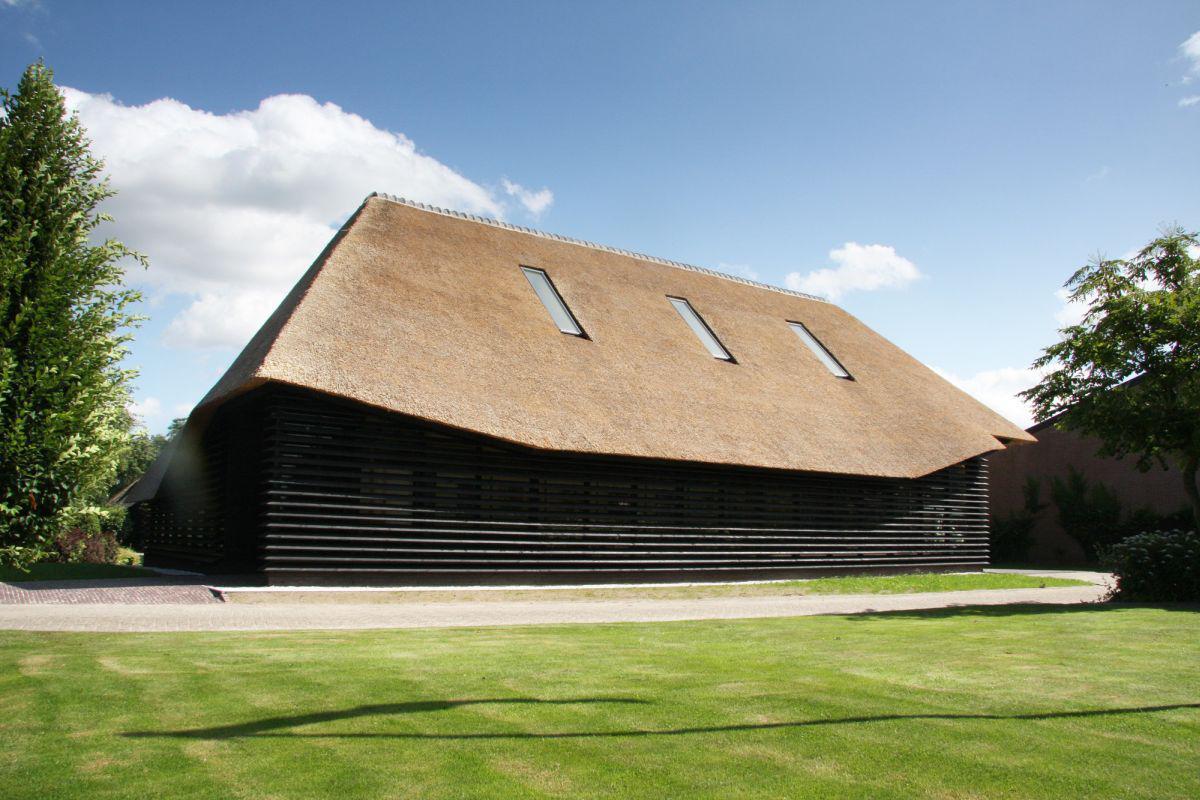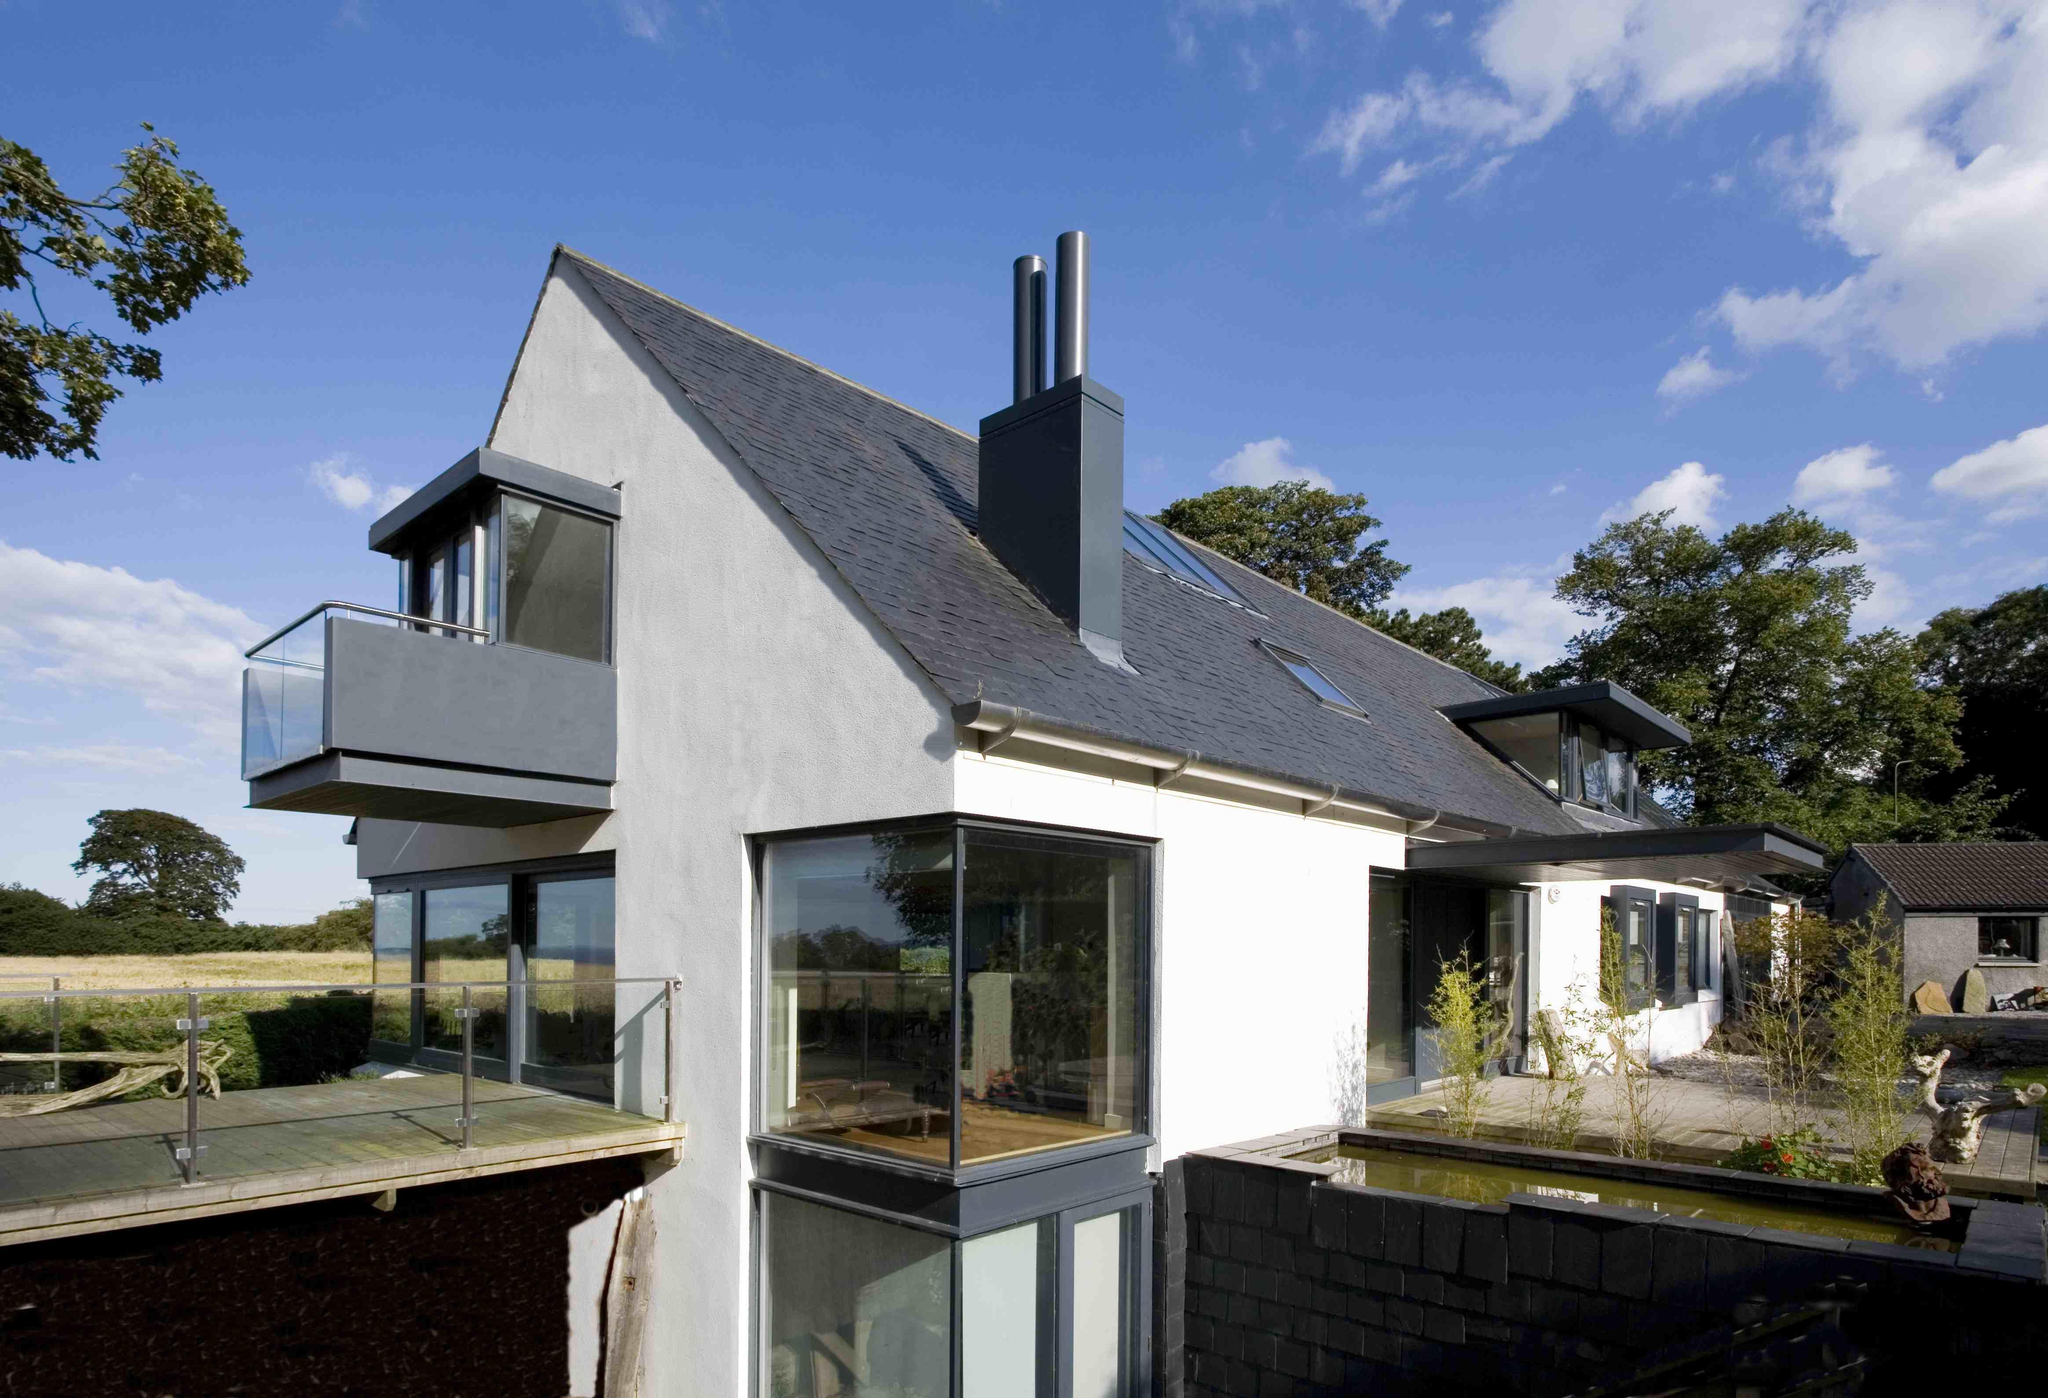The first image is the image on the left, the second image is the image on the right. Given the left and right images, does the statement "A mid century modern house has a flat roof." hold true? Answer yes or no. No. The first image is the image on the left, the second image is the image on the right. Given the left and right images, does the statement "One of the homes has a flat roof and the other has angular roof lines." hold true? Answer yes or no. No. 